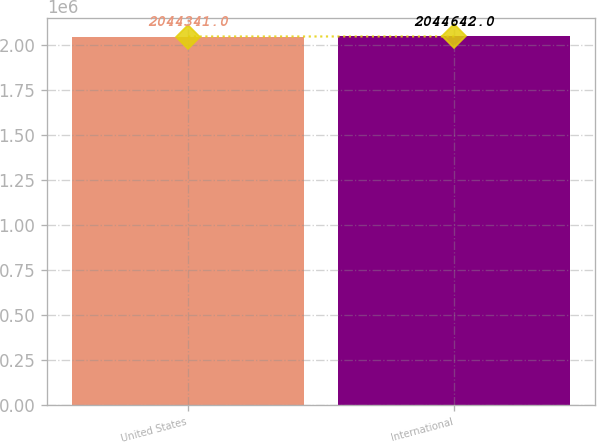Convert chart to OTSL. <chart><loc_0><loc_0><loc_500><loc_500><bar_chart><fcel>United States<fcel>International<nl><fcel>2.04434e+06<fcel>2.04464e+06<nl></chart> 